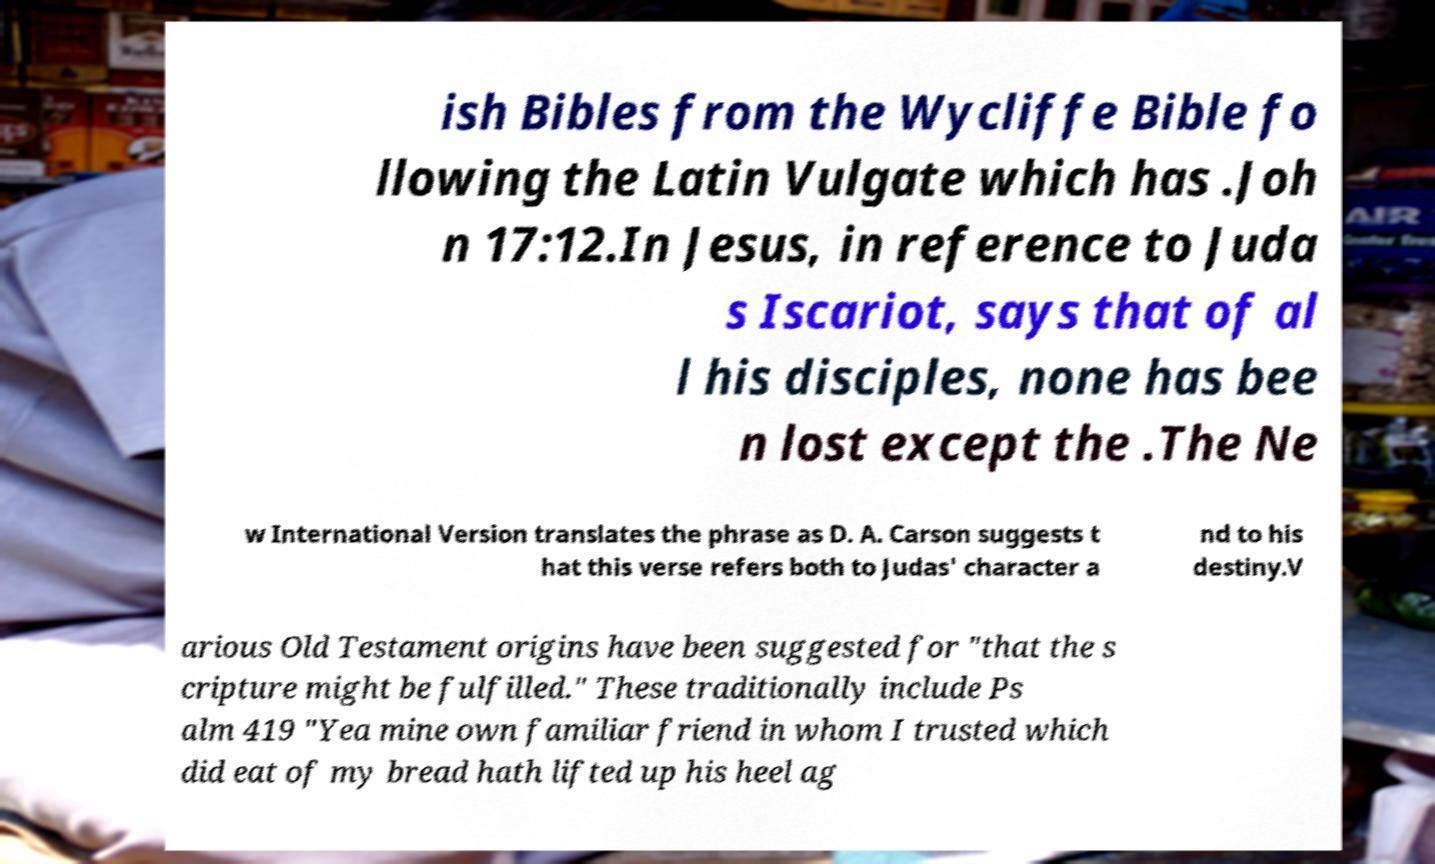I need the written content from this picture converted into text. Can you do that? ish Bibles from the Wycliffe Bible fo llowing the Latin Vulgate which has .Joh n 17:12.In Jesus, in reference to Juda s Iscariot, says that of al l his disciples, none has bee n lost except the .The Ne w International Version translates the phrase as D. A. Carson suggests t hat this verse refers both to Judas' character a nd to his destiny.V arious Old Testament origins have been suggested for "that the s cripture might be fulfilled." These traditionally include Ps alm 419 "Yea mine own familiar friend in whom I trusted which did eat of my bread hath lifted up his heel ag 